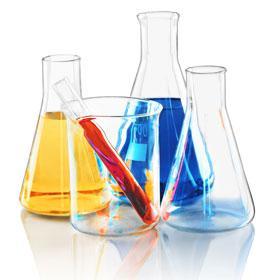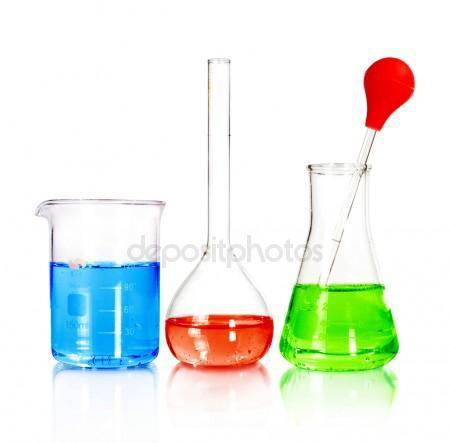The first image is the image on the left, the second image is the image on the right. Assess this claim about the two images: "One image shows exactly three containers of different colored liquids in a level row with no overlap, and one of the bottles has a round bottom and tall slender neck.". Correct or not? Answer yes or no. Yes. The first image is the image on the left, the second image is the image on the right. Considering the images on both sides, is "In the image on the right, the container furthest to the left contains a blue liquid." valid? Answer yes or no. Yes. 